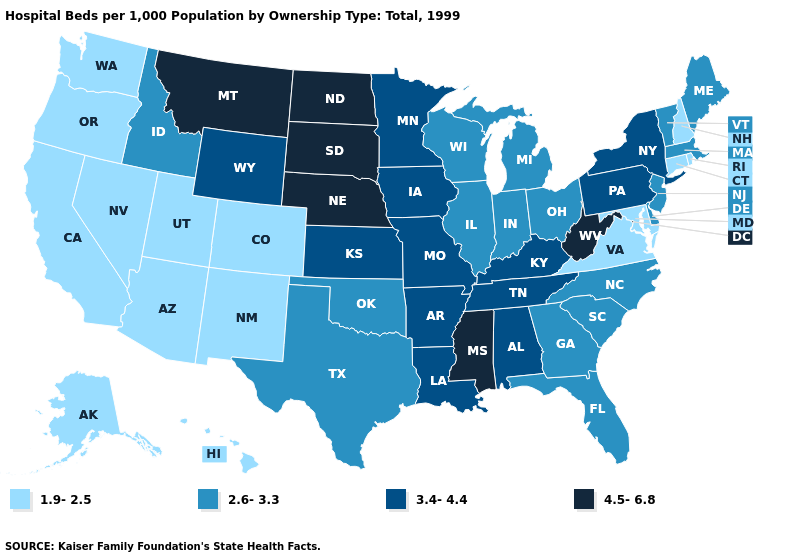Is the legend a continuous bar?
Quick response, please. No. Among the states that border Minnesota , does North Dakota have the highest value?
Concise answer only. Yes. Does the first symbol in the legend represent the smallest category?
Quick response, please. Yes. Among the states that border Illinois , does Wisconsin have the lowest value?
Write a very short answer. Yes. Is the legend a continuous bar?
Give a very brief answer. No. Among the states that border Ohio , does West Virginia have the highest value?
Keep it brief. Yes. Does Florida have a higher value than Utah?
Keep it brief. Yes. Does Kentucky have the lowest value in the South?
Short answer required. No. What is the lowest value in states that border South Dakota?
Answer briefly. 3.4-4.4. How many symbols are there in the legend?
Quick response, please. 4. Among the states that border Iowa , which have the highest value?
Write a very short answer. Nebraska, South Dakota. Which states hav the highest value in the West?
Write a very short answer. Montana. Name the states that have a value in the range 3.4-4.4?
Short answer required. Alabama, Arkansas, Iowa, Kansas, Kentucky, Louisiana, Minnesota, Missouri, New York, Pennsylvania, Tennessee, Wyoming. Which states have the highest value in the USA?
Quick response, please. Mississippi, Montana, Nebraska, North Dakota, South Dakota, West Virginia. What is the lowest value in the Northeast?
Keep it brief. 1.9-2.5. 